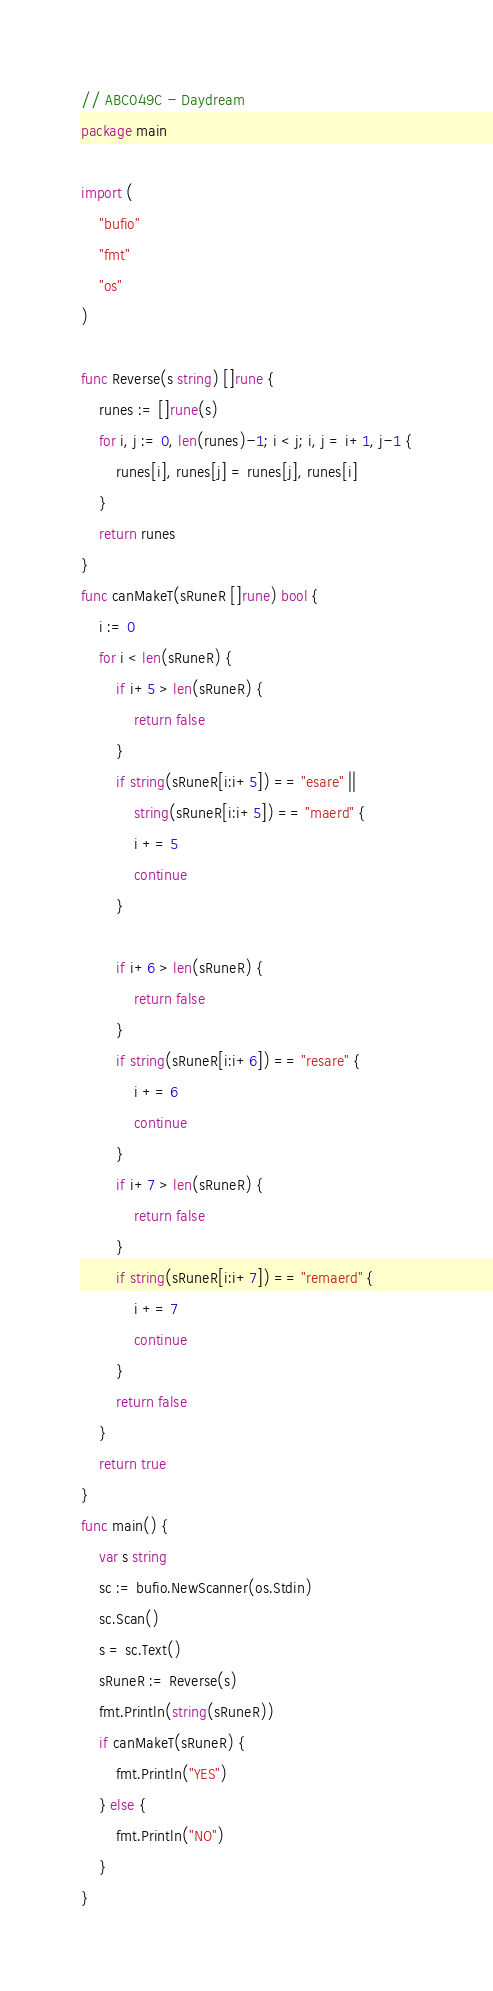Convert code to text. <code><loc_0><loc_0><loc_500><loc_500><_Go_>// ABC049C - Daydream
package main

import (
	"bufio"
	"fmt"
	"os"
)

func Reverse(s string) []rune {
	runes := []rune(s)
	for i, j := 0, len(runes)-1; i < j; i, j = i+1, j-1 {
		runes[i], runes[j] = runes[j], runes[i]
	}
	return runes
}
func canMakeT(sRuneR []rune) bool {
	i := 0
	for i < len(sRuneR) {
		if i+5 > len(sRuneR) {
			return false
		}
		if string(sRuneR[i:i+5]) == "esare" ||
			string(sRuneR[i:i+5]) == "maerd" {
			i += 5
			continue
		}

		if i+6 > len(sRuneR) {
			return false
		}
		if string(sRuneR[i:i+6]) == "resare" {
			i += 6
			continue
		}
		if i+7 > len(sRuneR) {
			return false
		}
		if string(sRuneR[i:i+7]) == "remaerd" {
			i += 7
			continue
		}
		return false
	}
	return true
}
func main() {
	var s string
	sc := bufio.NewScanner(os.Stdin)
	sc.Scan()
	s = sc.Text()
	sRuneR := Reverse(s)
	fmt.Println(string(sRuneR))
	if canMakeT(sRuneR) {
		fmt.Println("YES")
	} else {
		fmt.Println("NO")
	}
}
</code> 